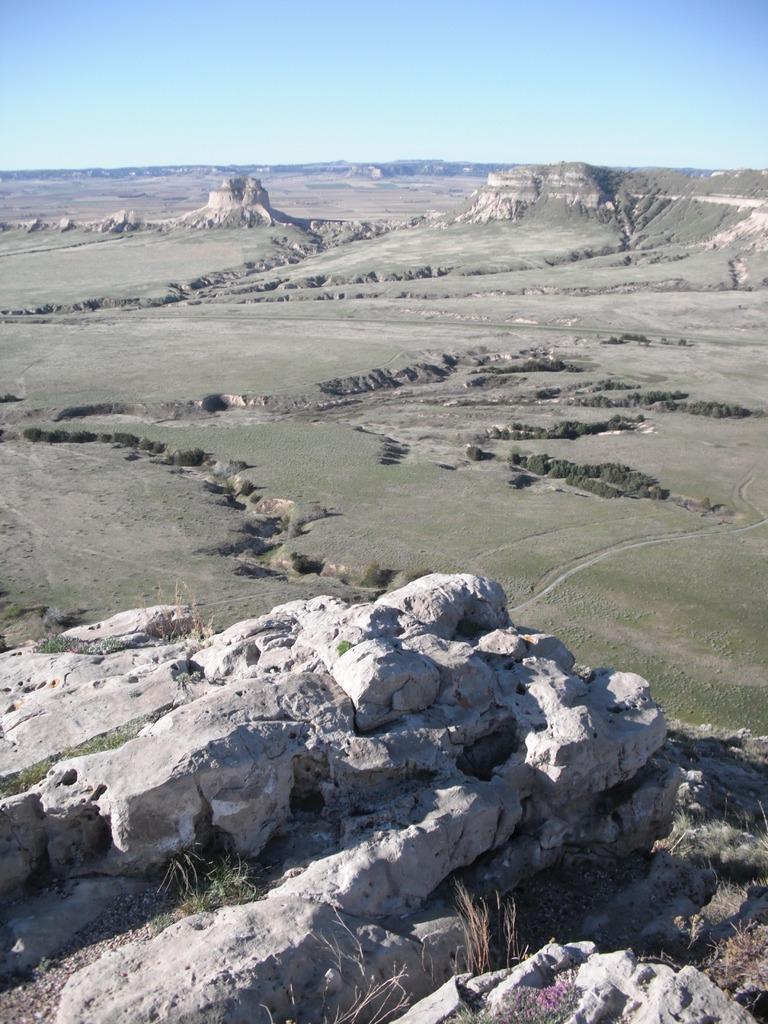Can you describe this image briefly? In this image I can see mountains and the grass. In the background I can see the sky. 